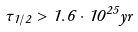<formula> <loc_0><loc_0><loc_500><loc_500>\tau _ { 1 / 2 } > 1 . 6 \cdot 1 0 ^ { 2 5 } y r</formula> 